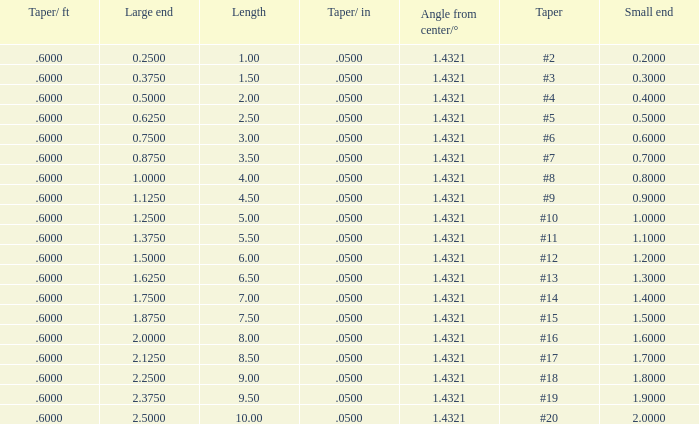Would you mind parsing the complete table? {'header': ['Taper/ ft', 'Large end', 'Length', 'Taper/ in', 'Angle from center/°', 'Taper', 'Small end'], 'rows': [['.6000', '0.2500', '1.00', '.0500', '1.4321', '#2', '0.2000'], ['.6000', '0.3750', '1.50', '.0500', '1.4321', '#3', '0.3000'], ['.6000', '0.5000', '2.00', '.0500', '1.4321', '#4', '0.4000'], ['.6000', '0.6250', '2.50', '.0500', '1.4321', '#5', '0.5000'], ['.6000', '0.7500', '3.00', '.0500', '1.4321', '#6', '0.6000'], ['.6000', '0.8750', '3.50', '.0500', '1.4321', '#7', '0.7000'], ['.6000', '1.0000', '4.00', '.0500', '1.4321', '#8', '0.8000'], ['.6000', '1.1250', '4.50', '.0500', '1.4321', '#9', '0.9000'], ['.6000', '1.2500', '5.00', '.0500', '1.4321', '#10', '1.0000'], ['.6000', '1.3750', '5.50', '.0500', '1.4321', '#11', '1.1000'], ['.6000', '1.5000', '6.00', '.0500', '1.4321', '#12', '1.2000'], ['.6000', '1.6250', '6.50', '.0500', '1.4321', '#13', '1.3000'], ['.6000', '1.7500', '7.00', '.0500', '1.4321', '#14', '1.4000'], ['.6000', '1.8750', '7.50', '.0500', '1.4321', '#15', '1.5000'], ['.6000', '2.0000', '8.00', '.0500', '1.4321', '#16', '1.6000'], ['.6000', '2.1250', '8.50', '.0500', '1.4321', '#17', '1.7000'], ['.6000', '2.2500', '9.00', '.0500', '1.4321', '#18', '1.8000'], ['.6000', '2.3750', '9.50', '.0500', '1.4321', '#19', '1.9000'], ['.6000', '2.5000', '10.00', '.0500', '1.4321', '#20', '2.0000']]} Which Taper/ft that has a Large end smaller than 0.5, and a Taper of #2? 0.6. 